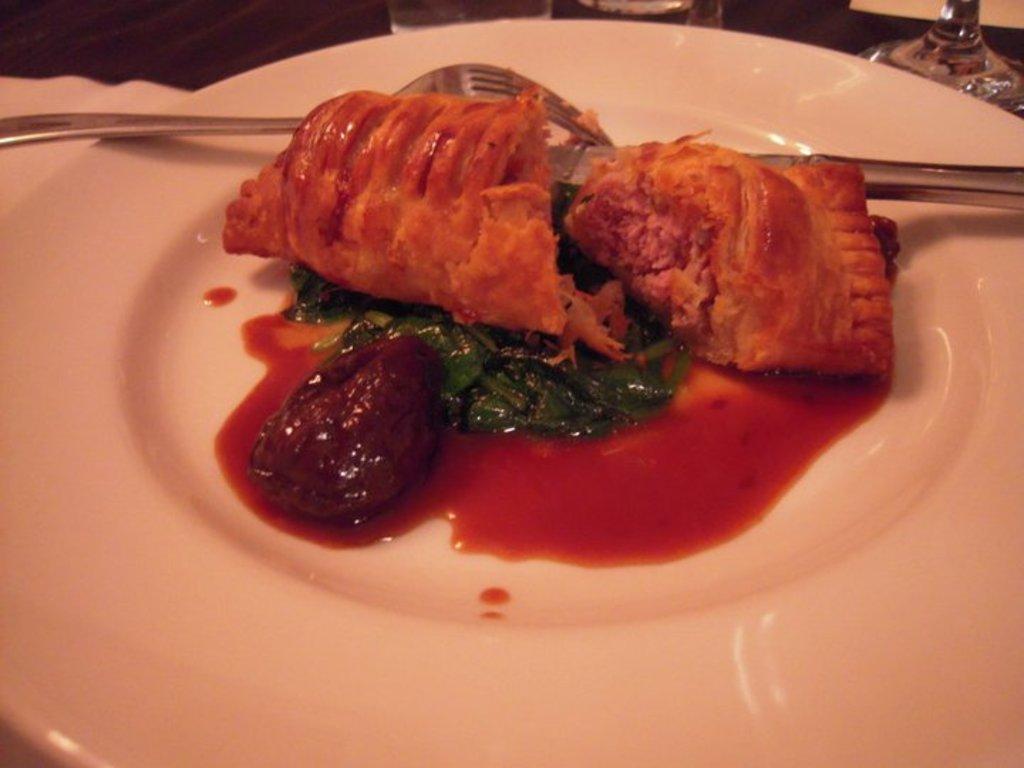Could you give a brief overview of what you see in this image? In this image there is a table and we can see a plate, food, spoon, knife and glasses placed on the table. 